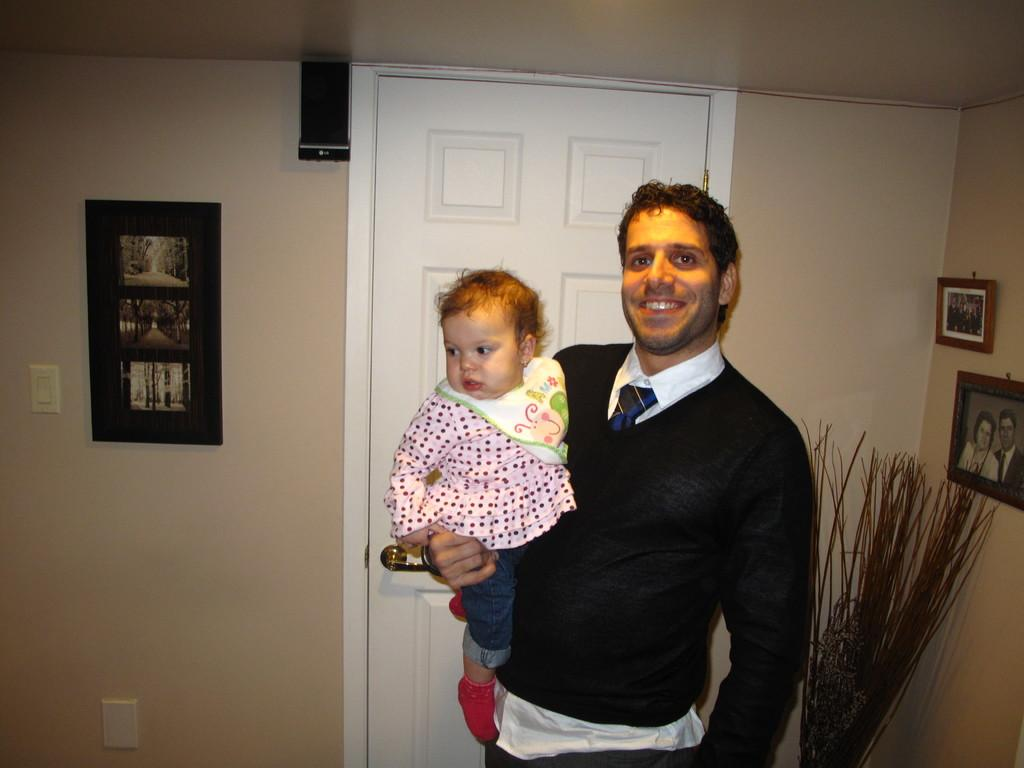What is the main subject in the middle of the image? There is a man standing in the middle of the image. What is the man doing in the image? The man is smiling and holding a baby. What can be seen behind the man? There is a wall behind the man, with frames on it. Can you describe any architectural features in the image? Yes, there is a door in the image. How many deer can be seen in the image? There are no deer present in the image. What type of star is visible in the image? There is no star visible in the image. 